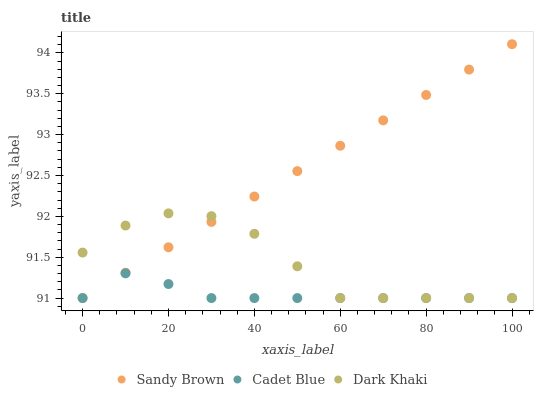Does Cadet Blue have the minimum area under the curve?
Answer yes or no. Yes. Does Sandy Brown have the maximum area under the curve?
Answer yes or no. Yes. Does Sandy Brown have the minimum area under the curve?
Answer yes or no. No. Does Cadet Blue have the maximum area under the curve?
Answer yes or no. No. Is Sandy Brown the smoothest?
Answer yes or no. Yes. Is Dark Khaki the roughest?
Answer yes or no. Yes. Is Cadet Blue the smoothest?
Answer yes or no. No. Is Cadet Blue the roughest?
Answer yes or no. No. Does Dark Khaki have the lowest value?
Answer yes or no. Yes. Does Sandy Brown have the highest value?
Answer yes or no. Yes. Does Cadet Blue have the highest value?
Answer yes or no. No. Does Cadet Blue intersect Sandy Brown?
Answer yes or no. Yes. Is Cadet Blue less than Sandy Brown?
Answer yes or no. No. Is Cadet Blue greater than Sandy Brown?
Answer yes or no. No. 